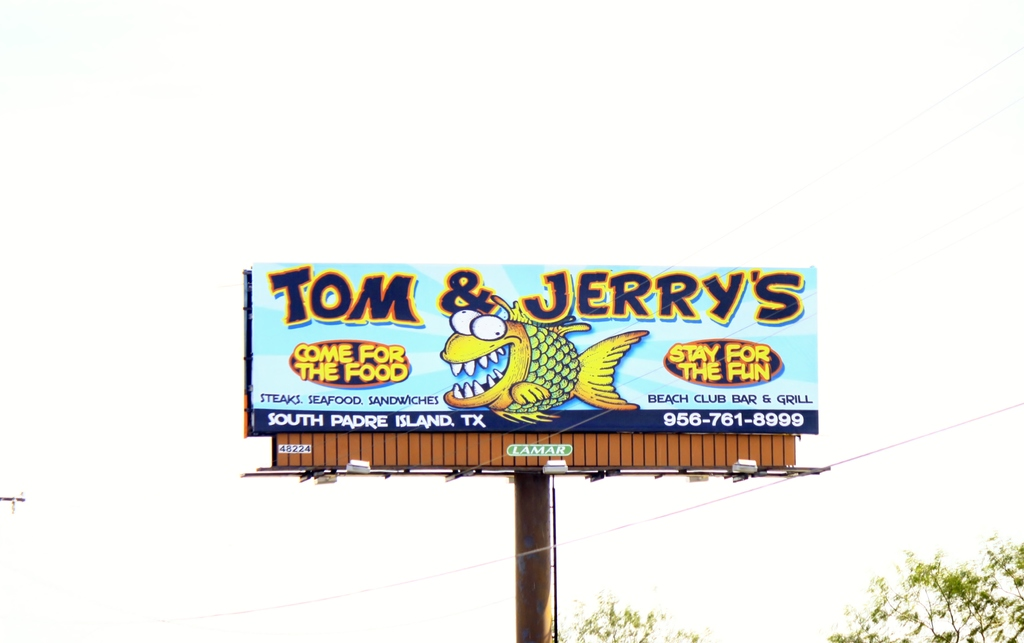What kind of dining atmosphere can we expect at Tom & Jerry's based on this advertisement? The advertising depicts Tom & Jerry's as a vibrant and lively spot, likely offering a casual and relaxed dining atmosphere conducive to fun experiences. The use of a cartoon alligator as a mascot and playful slogans imply a family-friendly environment, meant to attract visitors looking for a good meal in a cheerful setting. 